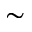<formula> <loc_0><loc_0><loc_500><loc_500>\sim</formula> 